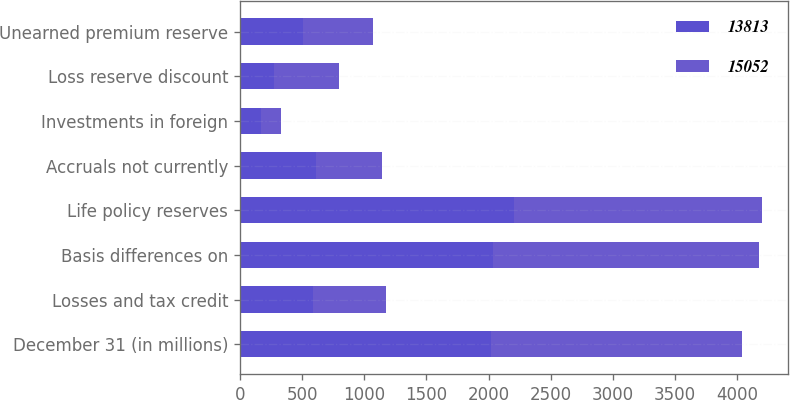Convert chart to OTSL. <chart><loc_0><loc_0><loc_500><loc_500><stacked_bar_chart><ecel><fcel>December 31 (in millions)<fcel>Losses and tax credit<fcel>Basis differences on<fcel>Life policy reserves<fcel>Accruals not currently<fcel>Investments in foreign<fcel>Loss reserve discount<fcel>Unearned premium reserve<nl><fcel>13813<fcel>2018<fcel>587<fcel>2038<fcel>2200<fcel>608<fcel>173<fcel>272<fcel>504<nl><fcel>15052<fcel>2017<fcel>587<fcel>2133<fcel>1996<fcel>532<fcel>159<fcel>526<fcel>566<nl></chart> 